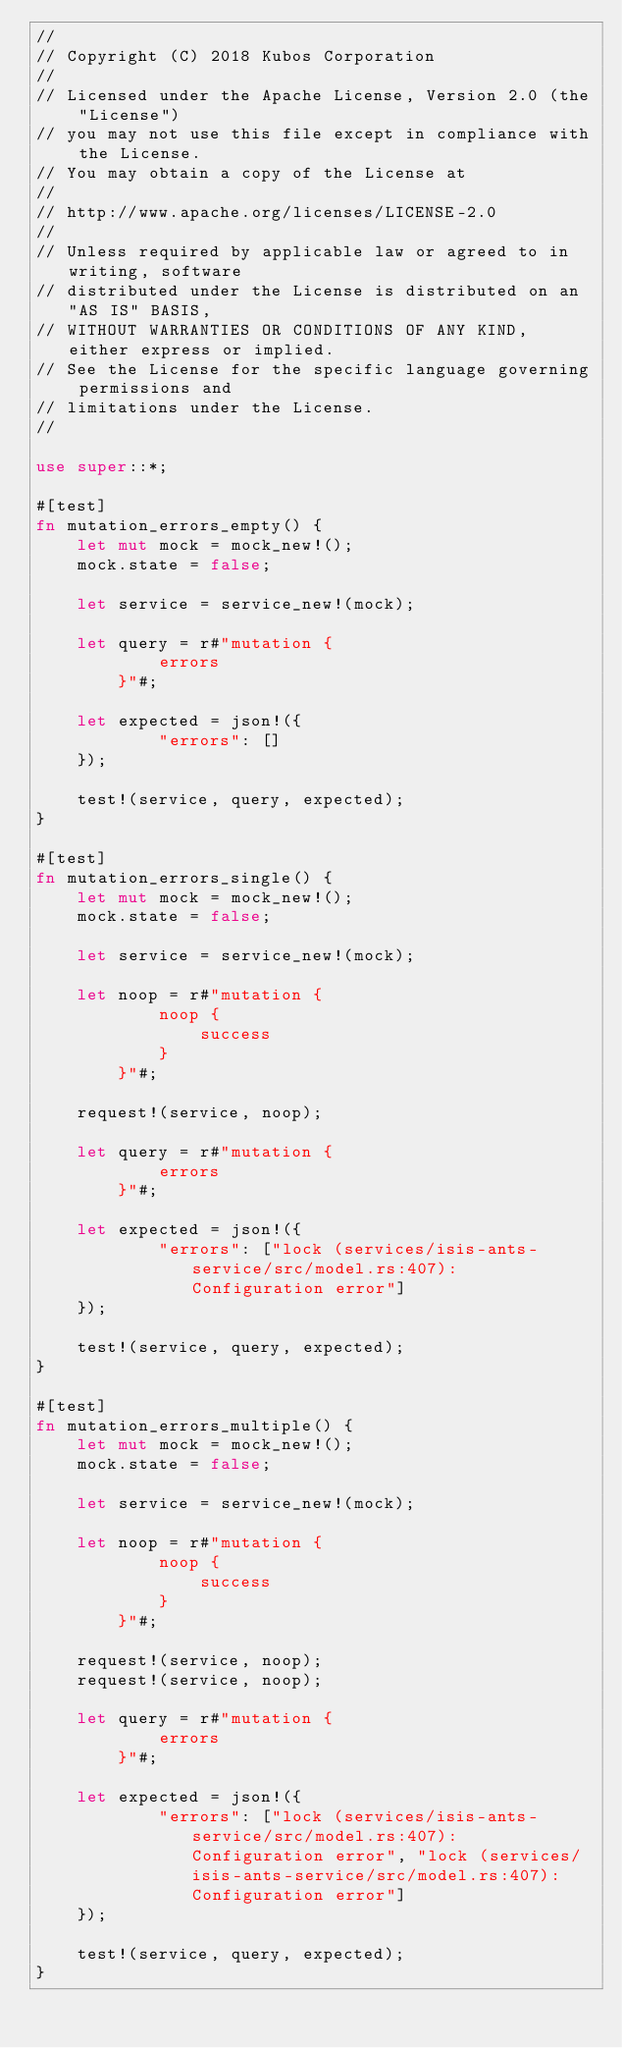Convert code to text. <code><loc_0><loc_0><loc_500><loc_500><_Rust_>//
// Copyright (C) 2018 Kubos Corporation
//
// Licensed under the Apache License, Version 2.0 (the "License")
// you may not use this file except in compliance with the License.
// You may obtain a copy of the License at
//
// http://www.apache.org/licenses/LICENSE-2.0
//
// Unless required by applicable law or agreed to in writing, software
// distributed under the License is distributed on an "AS IS" BASIS,
// WITHOUT WARRANTIES OR CONDITIONS OF ANY KIND, either express or implied.
// See the License for the specific language governing permissions and
// limitations under the License.
//

use super::*;

#[test]
fn mutation_errors_empty() {
    let mut mock = mock_new!();
    mock.state = false;

    let service = service_new!(mock);

    let query = r#"mutation {
            errors
        }"#;

    let expected = json!({
            "errors": []
    });

    test!(service, query, expected);
}

#[test]
fn mutation_errors_single() {
    let mut mock = mock_new!();
    mock.state = false;

    let service = service_new!(mock);

    let noop = r#"mutation {
            noop {
                success
            }
        }"#;

    request!(service, noop);

    let query = r#"mutation {
            errors
        }"#;

    let expected = json!({
            "errors": ["lock (services/isis-ants-service/src/model.rs:407): Configuration error"]
    });

    test!(service, query, expected);
}

#[test]
fn mutation_errors_multiple() {
    let mut mock = mock_new!();
    mock.state = false;

    let service = service_new!(mock);

    let noop = r#"mutation {
            noop {
                success
            }
        }"#;

    request!(service, noop);
    request!(service, noop);

    let query = r#"mutation {
            errors
        }"#;

    let expected = json!({
            "errors": ["lock (services/isis-ants-service/src/model.rs:407): Configuration error", "lock (services/isis-ants-service/src/model.rs:407): Configuration error"]
    });

    test!(service, query, expected);
}
</code> 